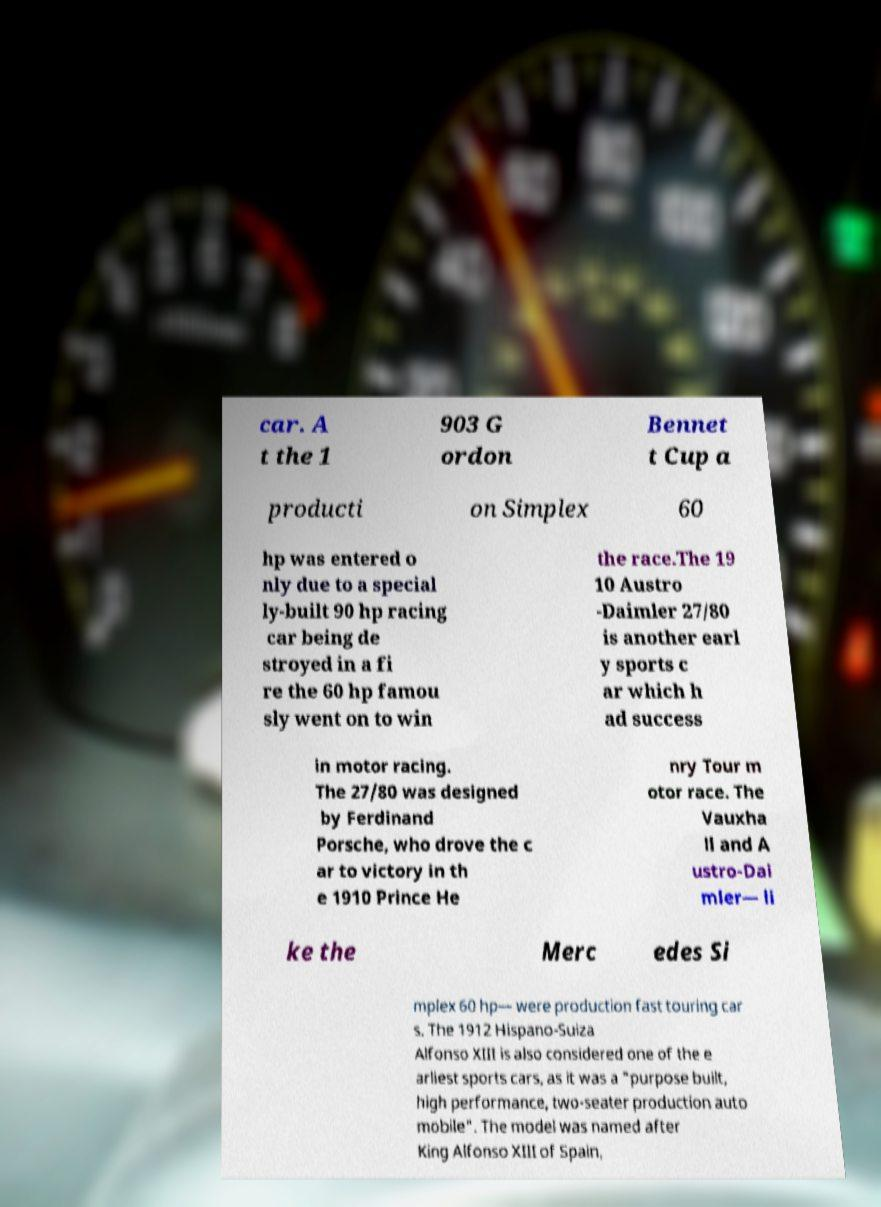There's text embedded in this image that I need extracted. Can you transcribe it verbatim? car. A t the 1 903 G ordon Bennet t Cup a producti on Simplex 60 hp was entered o nly due to a special ly-built 90 hp racing car being de stroyed in a fi re the 60 hp famou sly went on to win the race.The 19 10 Austro -Daimler 27/80 is another earl y sports c ar which h ad success in motor racing. The 27/80 was designed by Ferdinand Porsche, who drove the c ar to victory in th e 1910 Prince He nry Tour m otor race. The Vauxha ll and A ustro-Dai mler— li ke the Merc edes Si mplex 60 hp— were production fast touring car s. The 1912 Hispano-Suiza Alfonso XIII is also considered one of the e arliest sports cars, as it was a "purpose built, high performance, two-seater production auto mobile". The model was named after King Alfonso XIII of Spain, 